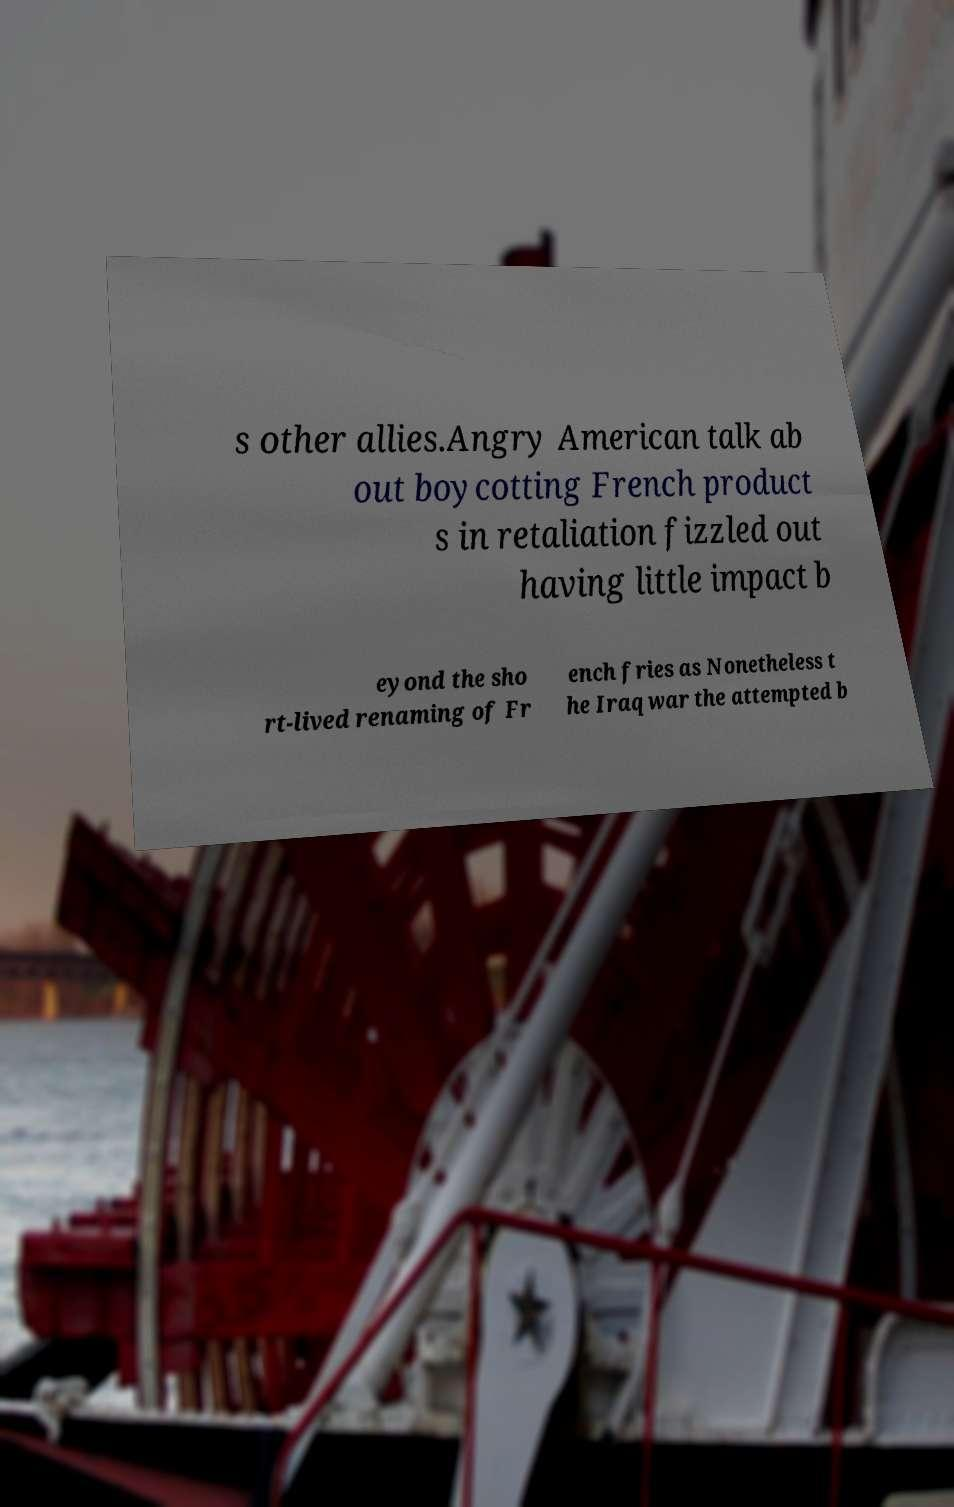Could you extract and type out the text from this image? s other allies.Angry American talk ab out boycotting French product s in retaliation fizzled out having little impact b eyond the sho rt-lived renaming of Fr ench fries as Nonetheless t he Iraq war the attempted b 